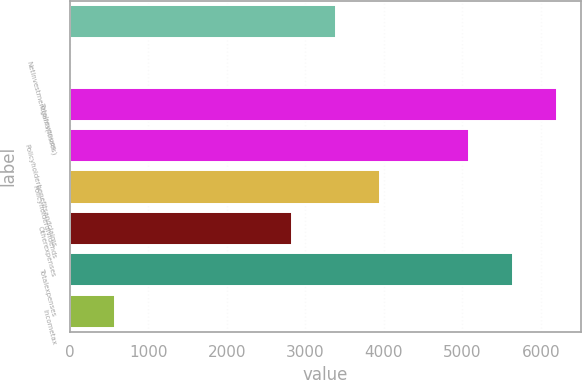Convert chart to OTSL. <chart><loc_0><loc_0><loc_500><loc_500><bar_chart><ecel><fcel>Netinvestmentgains(losses)<fcel>Totalrevenues<fcel>Policyholderbenefitsandclaims<fcel>Policyholderdividends<fcel>Otherexpenses<fcel>Totalexpenses<fcel>Incometax<nl><fcel>3392.2<fcel>19<fcel>6203.2<fcel>5078.8<fcel>3954.4<fcel>2830<fcel>5641<fcel>581.2<nl></chart> 